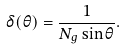<formula> <loc_0><loc_0><loc_500><loc_500>\delta ( \theta ) = \frac { 1 } { N _ { g } \sin \theta } .</formula> 